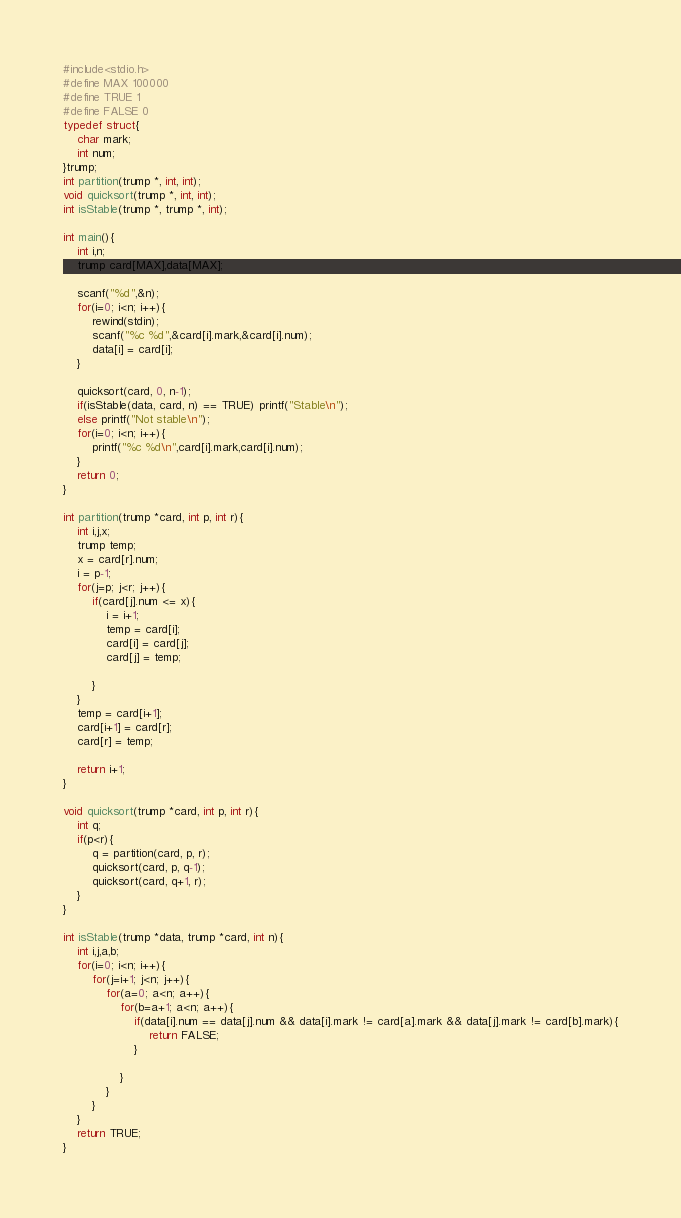<code> <loc_0><loc_0><loc_500><loc_500><_C_>#include<stdio.h>
#define MAX 100000
#define TRUE 1
#define FALSE 0
typedef struct{
    char mark;
    int num;
}trump;
int partition(trump *, int, int);
void quicksort(trump *, int, int);
int isStable(trump *, trump *, int);

int main(){
    int i,n;
    trump card[MAX],data[MAX];
    
    scanf("%d",&n);
    for(i=0; i<n; i++){
        rewind(stdin);
        scanf("%c %d",&card[i].mark,&card[i].num);
        data[i] = card[i];
    }
    
    quicksort(card, 0, n-1);
    if(isStable(data, card, n) == TRUE) printf("Stable\n");
    else printf("Not stable\n");
    for(i=0; i<n; i++){
        printf("%c %d\n",card[i].mark,card[i].num);
    }
    return 0;
}

int partition(trump *card, int p, int r){
    int i,j,x;
    trump temp;
    x = card[r].num;
    i = p-1;
    for(j=p; j<r; j++){
        if(card[j].num <= x){
            i = i+1;
            temp = card[i];
            card[i] = card[j];
            card[j] = temp;
            
        }
    }
    temp = card[i+1];
    card[i+1] = card[r];
    card[r] = temp;
   
    return i+1;
}

void quicksort(trump *card, int p, int r){
    int q;
    if(p<r){
        q = partition(card, p, r);
        quicksort(card, p, q-1);
        quicksort(card, q+1, r);
    }
}

int isStable(trump *data, trump *card, int n){
    int i,j,a,b;
    for(i=0; i<n; i++){
        for(j=i+1; j<n; j++){
            for(a=0; a<n; a++){
                for(b=a+1; a<n; a++){
                    if(data[i].num == data[j].num && data[i].mark != card[a].mark && data[j].mark != card[b].mark){
                        return FALSE;
                    }
                    
                }
            }
        }
    }
    return TRUE;
}




</code> 